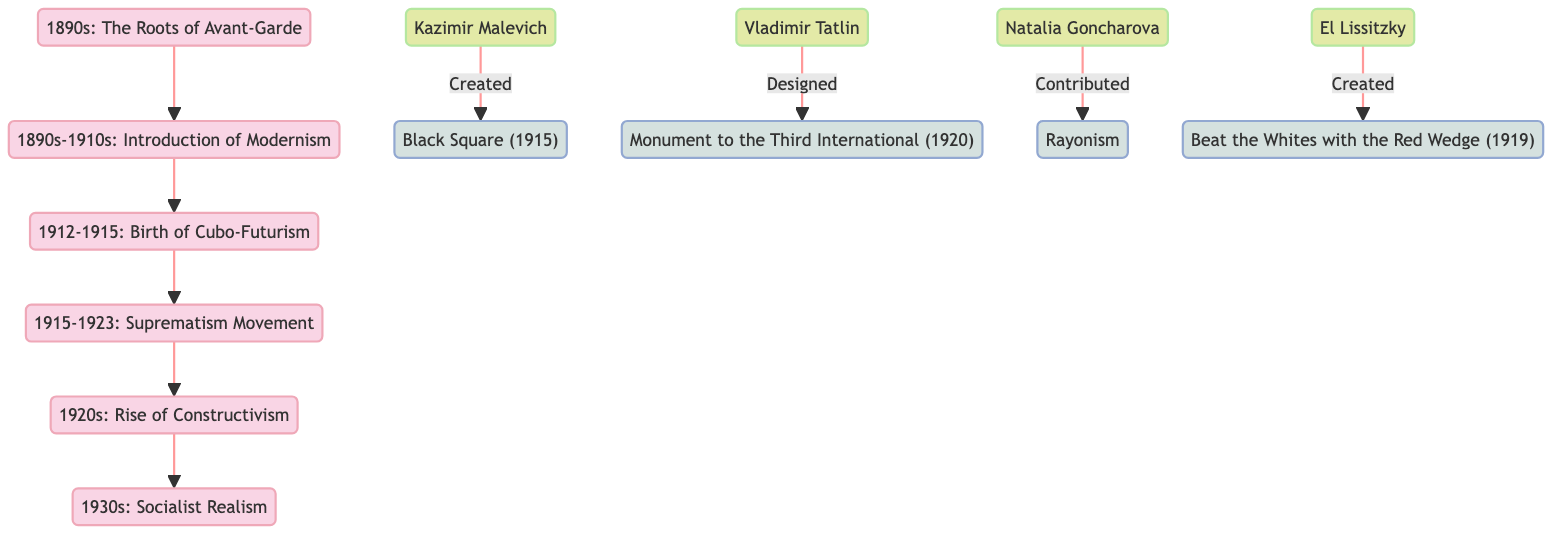What movement was introduced in the 1890s? The diagram shows that the first movement introduced is "Modernism" in the 1890s-1910s timeline segment.
Answer: Modernism How many key artistic movements are shown in the diagram? By examining the flowchart, there are five artistic movements depicted: Modernism, Cubo-Futurism, Suprematism, Constructivism, and Socialist Realism.
Answer: Five Which artist created "Black Square"? The diagram indicates a direct line from the artist Kazimir Malevich to the artwork "Black Square," showing he created it.
Answer: Kazimir Malevich What is the title of the work designed by Vladimir Tatlin? From the diagram, there is a link from Vladimir Tatlin to "Monument to the Third International," confirming he designed this work.
Answer: Monument to the Third International What movement is associated with El Lissitzky? The diagram indicates that El Lissitzky is connected to the artwork "Beat the Whites with the Red Wedge," which is part of the wider context of the avant-garde movements.
Answer: Beat the Whites with the Red Wedge Which movement directly followed Cubo-Futurism? By following the arrows in the flowchart, we see that Suprematism directly follows Cubo-Futurism in the timeline.
Answer: Suprematism What decade is labeled for the rise of Constructivism? The diagram specifies the decade of the 1920s for the rise of Constructivism based on its timeline placement.
Answer: 1920s Which two artists contributed to Rayonism? The diagram mentions that Natalia Goncharova contributed to Rayonism but does not specify any other artist. Therefore, she is the only mentioned contributor in the chart.
Answer: Natalia Goncharova How is the relationship between Modernism and Cubo-Futurism depicted? In the diagram, Modernism is a precursor to Cubo-Futurism, indicated by a direct flow from Modernism to Cubo-Futurism in the timeline.
Answer: Precursor 